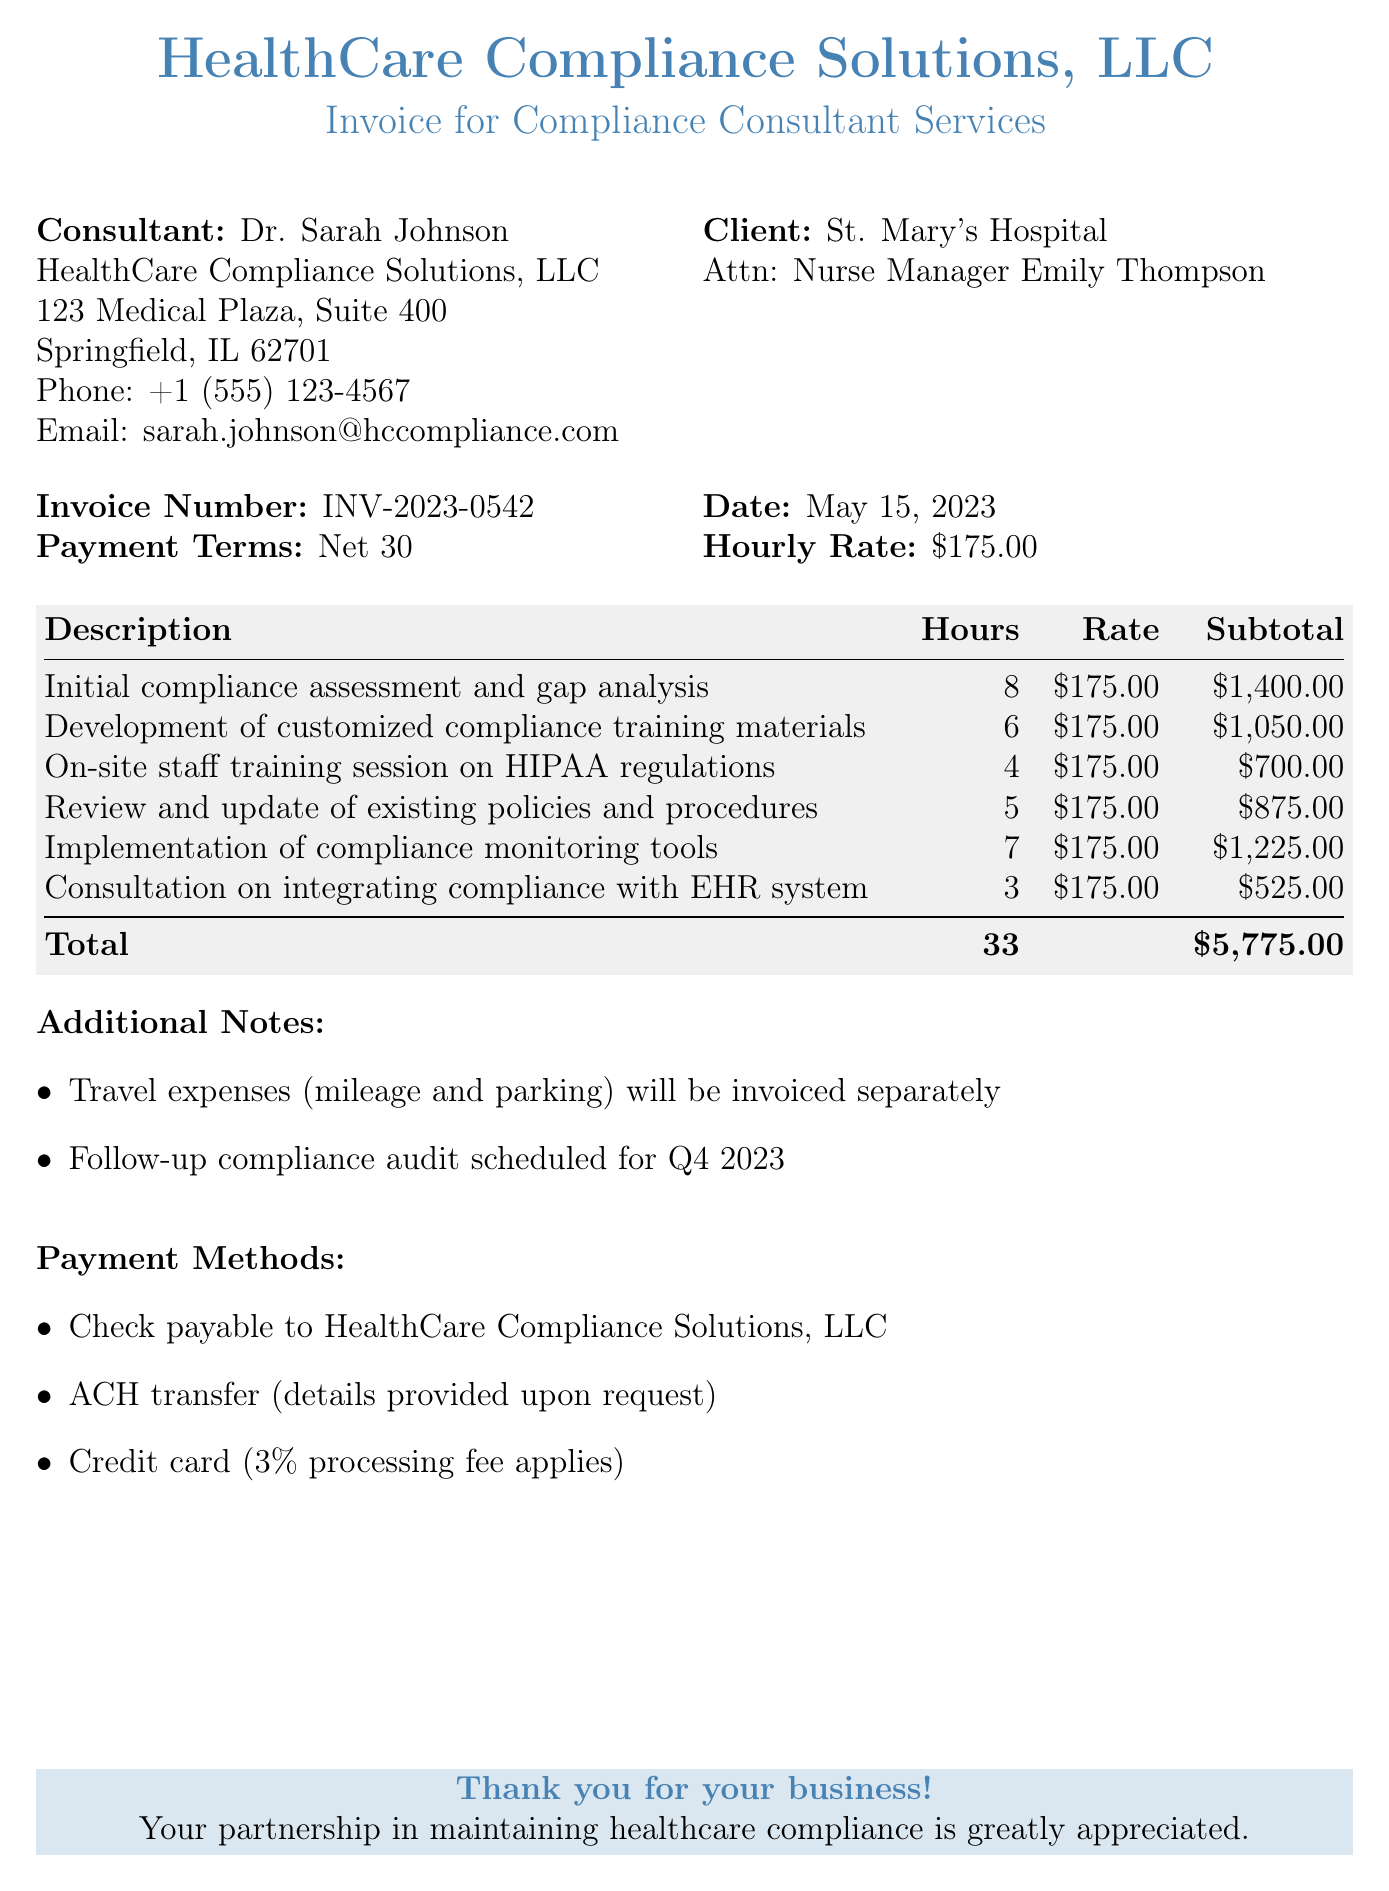What is the consultant's name? The consultant's name is listed at the top of the document under the consultant details section.
Answer: Dr. Sarah Johnson What is the client's name? The client's name is provided in the document under the client details section.
Answer: St. Mary's Hospital What is the total amount due? The total amount is clearly stated in the summary section of the invoice.
Answer: $5,775.00 How many hours did the consultant work in total? The total hours worked can be found in the summary of tasks performed in the document.
Answer: 33 What task took the most hours? To find this, you would look for the task with the highest hours listed in the tasks performed section.
Answer: Initial compliance assessment and gap analysis What is the hourly rate charged by the consultant? The hourly rate is specified in the invoice details section of the document.
Answer: $175.00 When was the invoice issued? The invoice date is explicitly mentioned in the header of the document.
Answer: May 15, 2023 What are the payment terms? Payment terms are specifically outlined in the invoice details section, indicating when the payment is expected.
Answer: Net 30 Is there a follow-up compliance audit scheduled? The additional notes section states whether a follow-up is scheduled or not.
Answer: Yes, for Q4 2023 